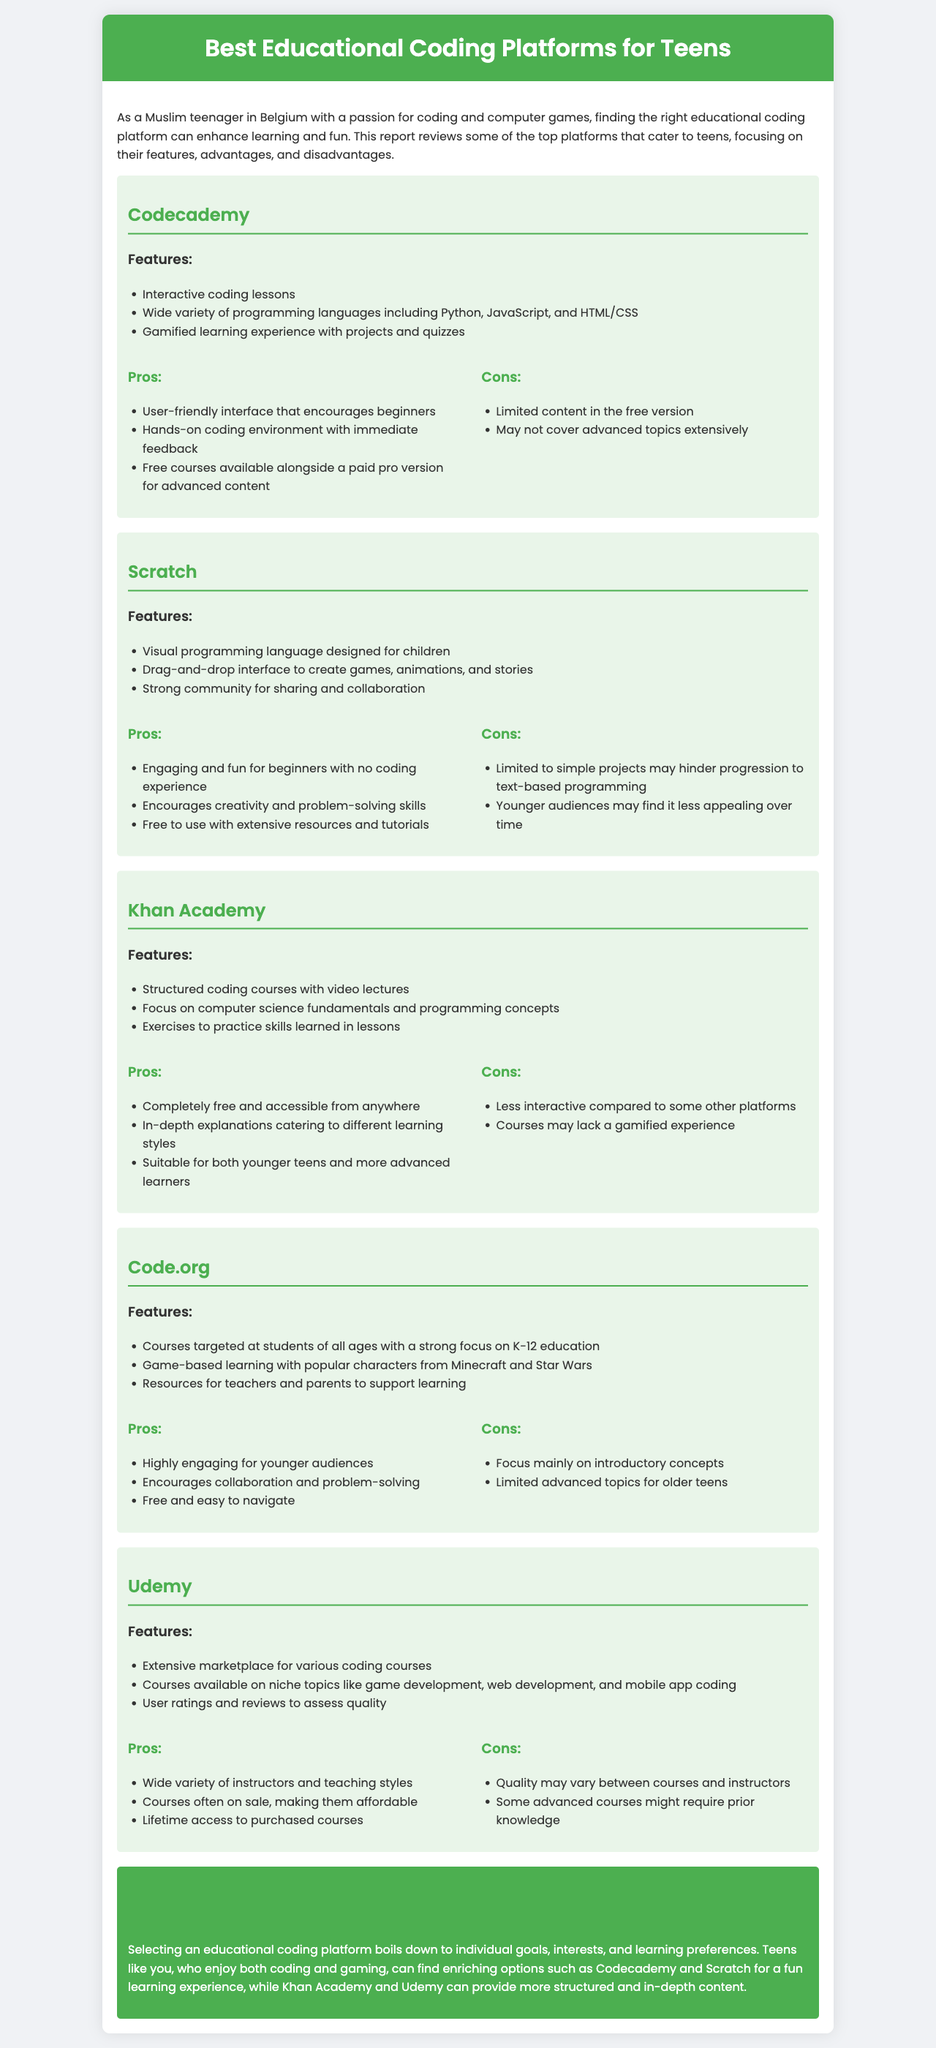What is the title of the report? The title is mentioned in the header section, which states the main topic of the document.
Answer: Best Educational Coding Platforms for Teens How many coding platforms are reviewed in the document? The document provides reviews for a specific number of platforms listed in separate sections.
Answer: Five Which platform has a drag-and-drop interface? The feature of having a drag-and-drop interface is mentioned specifically under the platform section.
Answer: Scratch What is a disadvantage of Codecademy? The cons of Codecademy are provided in a list, mentioning specific limitations.
Answer: Limited content in the free version Which platform is completely free and accessible from anywhere? This information is highlighted in the pros section of the respective platform.
Answer: Khan Academy Which two platforms are recommended for teens who enjoy coding and gaming? The conclusion summarizes the platforms that fulfill this interest.
Answer: Codecademy and Scratch What type of learning experience does Code.org focus on? The document describes the learning experience offered by Code.org, which can be summarized.
Answer: Game-based learning What type of courses does Udemy offer? The document describes the various types of courses available on this platform.
Answer: Extensive marketplace for various coding courses 